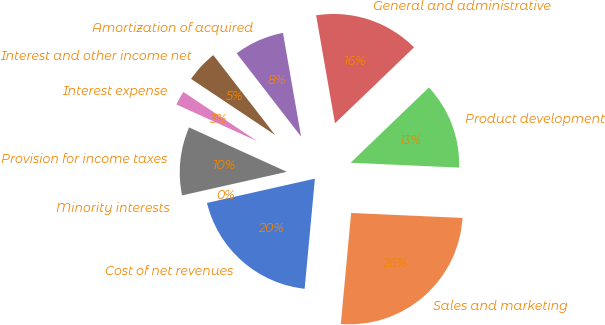Convert chart. <chart><loc_0><loc_0><loc_500><loc_500><pie_chart><fcel>Cost of net revenues<fcel>Sales and marketing<fcel>Product development<fcel>General and administrative<fcel>Amortization of acquired<fcel>Interest and other income net<fcel>Interest expense<fcel>Provision for income taxes<fcel>Minority interests<nl><fcel>20.0%<fcel>25.77%<fcel>12.89%<fcel>15.57%<fcel>7.73%<fcel>5.15%<fcel>2.58%<fcel>10.31%<fcel>0.0%<nl></chart> 